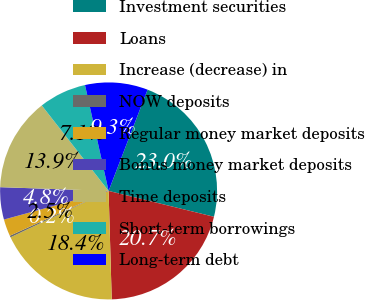Convert chart to OTSL. <chart><loc_0><loc_0><loc_500><loc_500><pie_chart><fcel>Investment securities<fcel>Loans<fcel>Increase (decrease) in<fcel>NOW deposits<fcel>Regular money market deposits<fcel>Bonus money market deposits<fcel>Time deposits<fcel>Short-term borrowings<fcel>Long-term debt<nl><fcel>22.98%<fcel>20.71%<fcel>18.43%<fcel>0.25%<fcel>2.53%<fcel>4.8%<fcel>13.89%<fcel>7.07%<fcel>9.34%<nl></chart> 